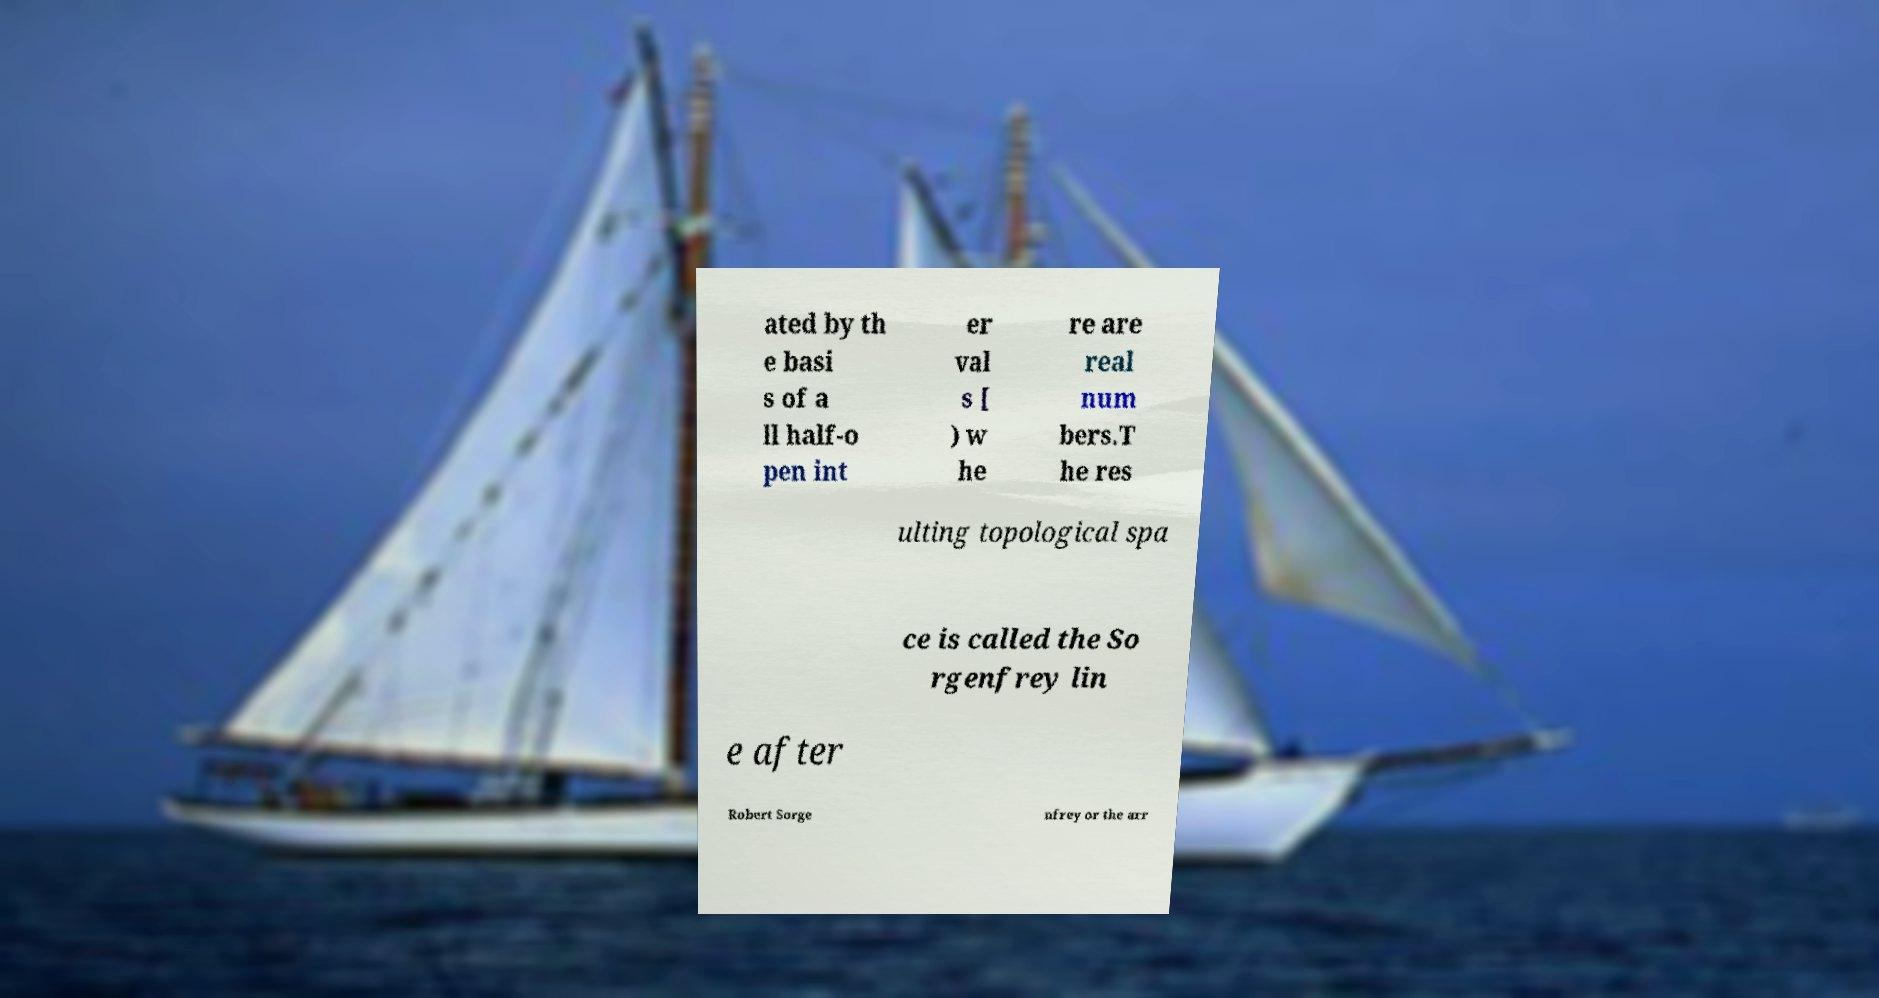Could you assist in decoding the text presented in this image and type it out clearly? ated by th e basi s of a ll half-o pen int er val s [ ) w he re are real num bers.T he res ulting topological spa ce is called the So rgenfrey lin e after Robert Sorge nfrey or the arr 